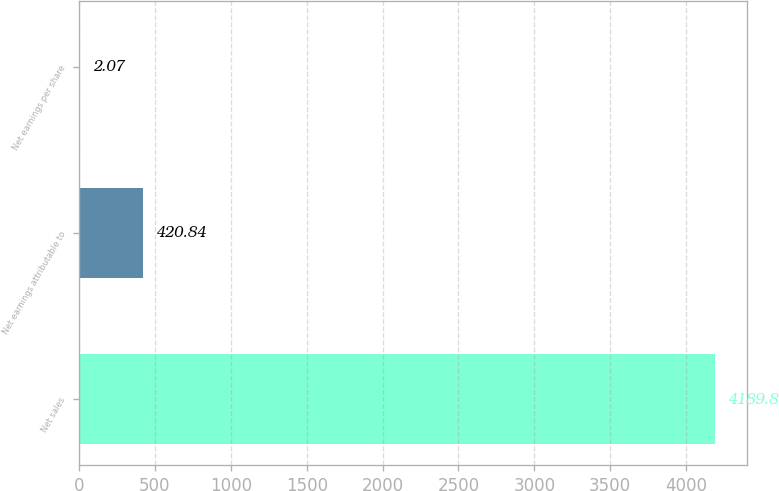Convert chart. <chart><loc_0><loc_0><loc_500><loc_500><bar_chart><fcel>Net sales<fcel>Net earnings attributable to<fcel>Net earnings per share<nl><fcel>4189.8<fcel>420.84<fcel>2.07<nl></chart> 